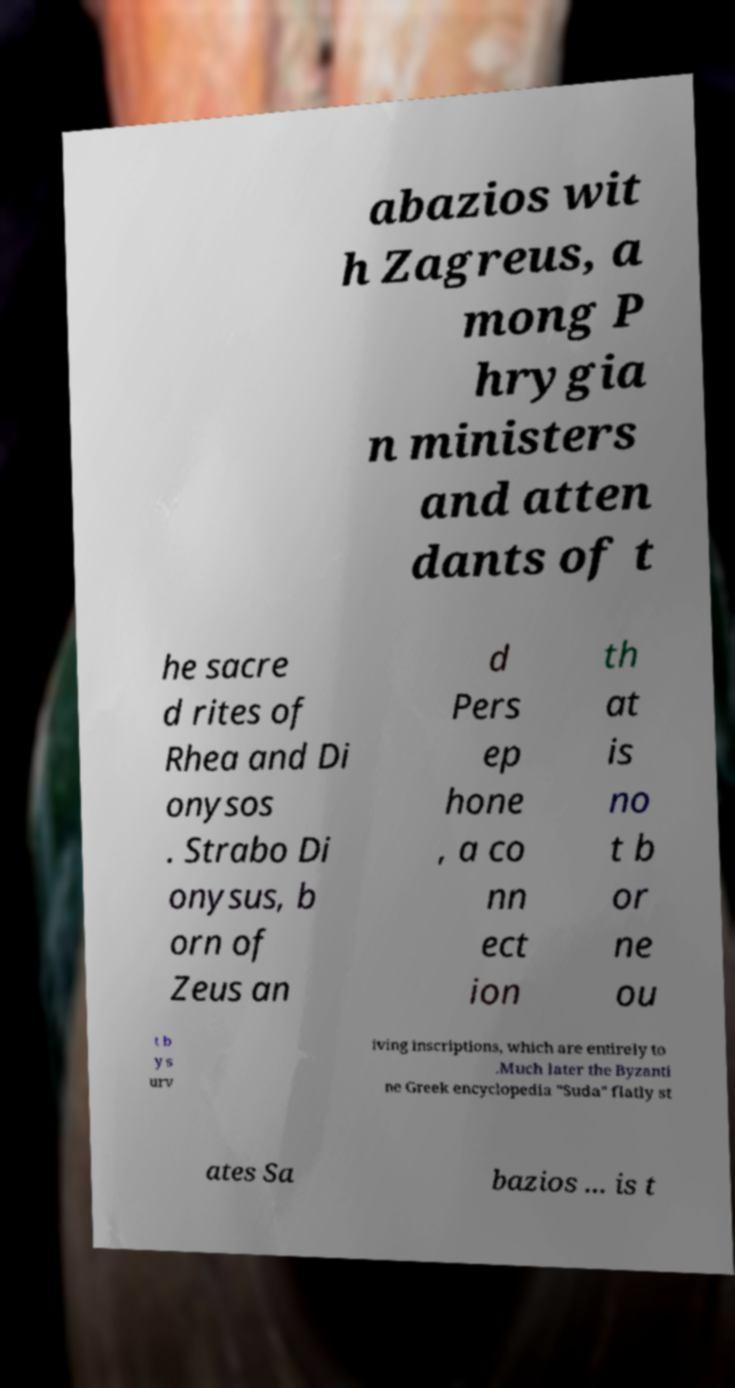Could you extract and type out the text from this image? abazios wit h Zagreus, a mong P hrygia n ministers and atten dants of t he sacre d rites of Rhea and Di onysos . Strabo Di onysus, b orn of Zeus an d Pers ep hone , a co nn ect ion th at is no t b or ne ou t b y s urv iving inscriptions, which are entirely to .Much later the Byzanti ne Greek encyclopedia "Suda" flatly st ates Sa bazios ... is t 